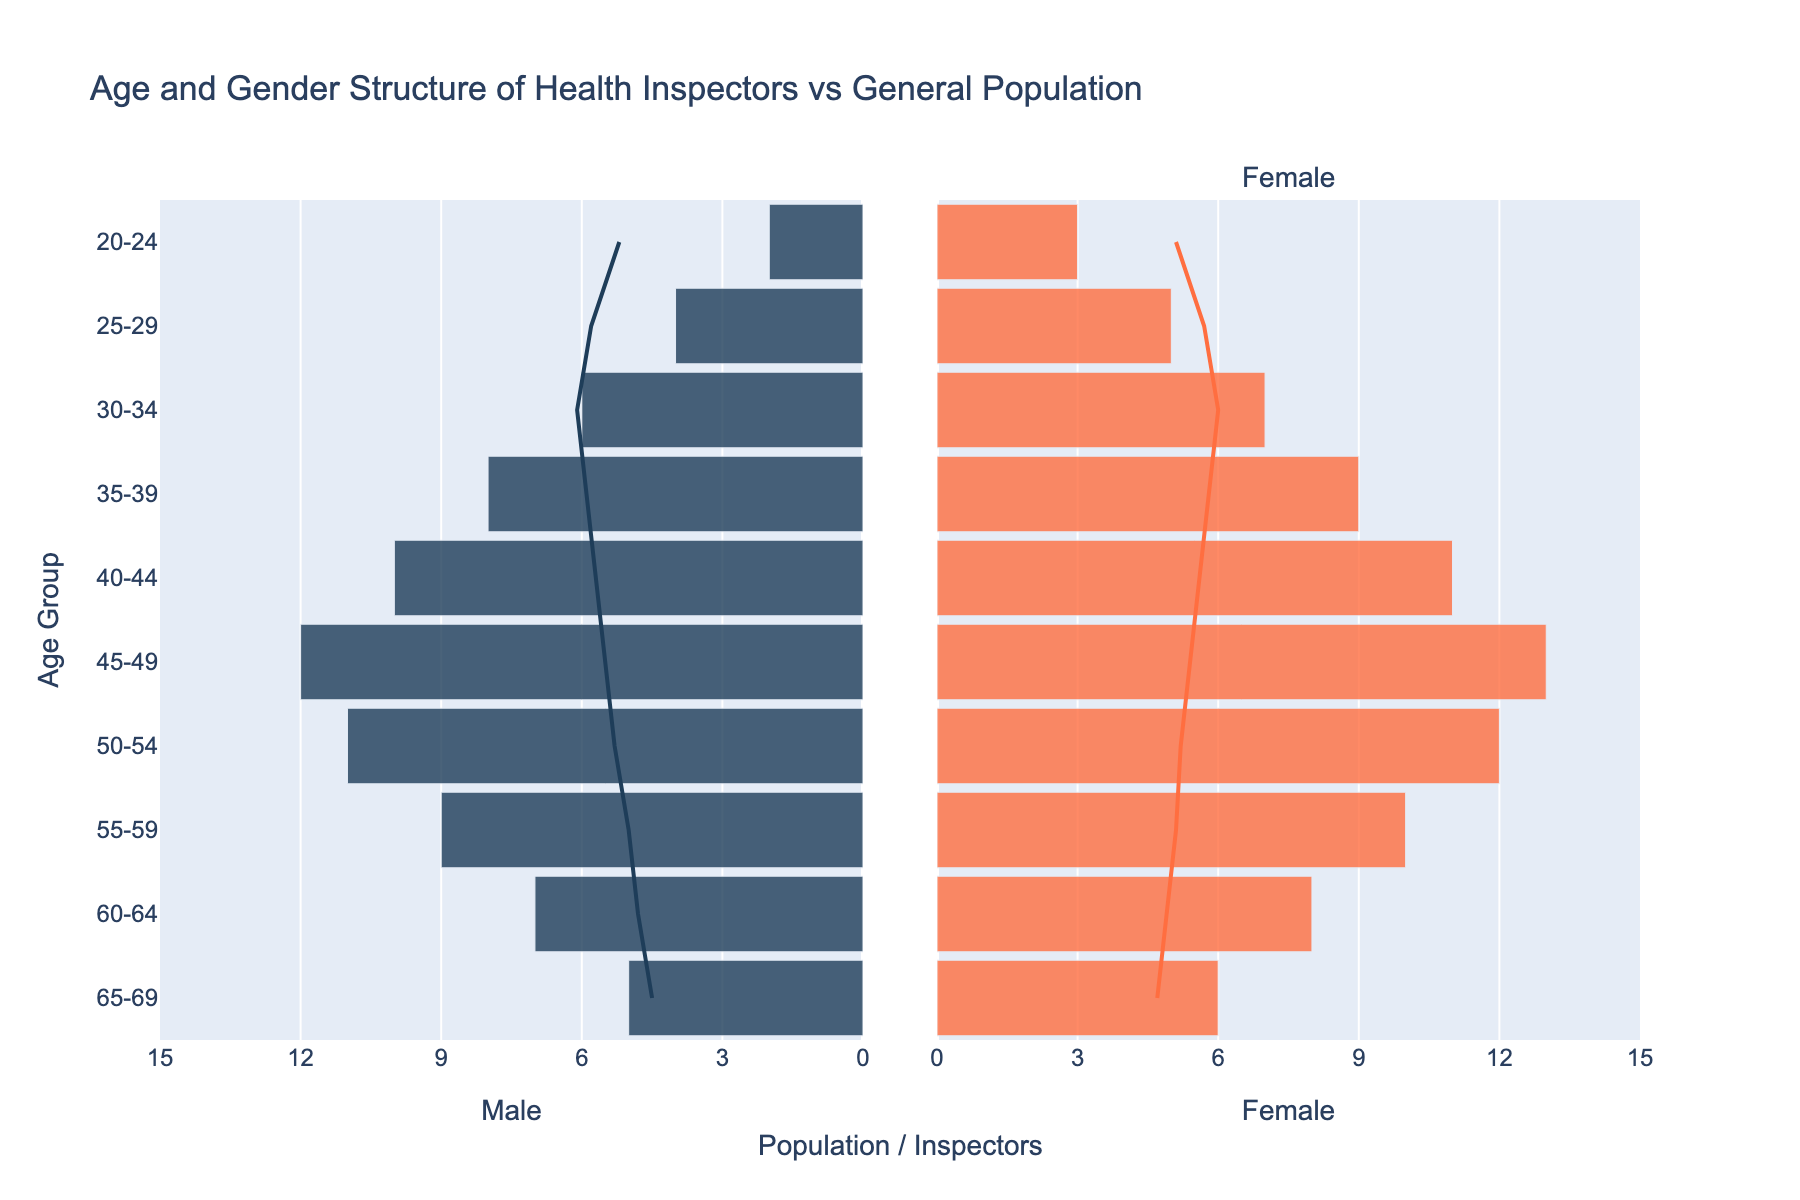What is the title of the figure? The title is usually located at the top of the figure and serves to give a brief idea about the content of the graph. In this case, it mentions the comparison of health inspectors and general population by age and gender.
Answer: Age and Gender Structure of Health Inspectors vs General Population What is the age group with the highest number of female health inspectors? By looking at the horizontal bar lengths on the right side of the population pyramid, we find the longest bar, indicating the largest number. For female health inspectors, the age group 45-49 has the longest bar.
Answer: 45-49 How do the numbers of male and female health inspectors in the 30-34 age group compare? In the 30-34 age group, the lengths of the bars on the left side (male inspectors) and right side (female inspectors) are almost even, representing 6 male inspectors and 7 female inspectors.
Answer: 6 male inspectors and 7 female inspectors Which age group shows the largest difference between male and female populations? To find this, we look at the gaps between the male and female population lines across age groups. The largest difference can be seen in the 65-69 age group where the male line falls short of the female line.
Answer: 65-69 How do the male and female populations compare across different age groups? By examining the lines representing the general population on both sides, we can see that the lines follow a similar pattern but deviate slightly in older age groups, like 65-69, where more females are present than males.
Answer: Females outnumber males, especially in older age groups In which age group are the male inspectors most overrepresented compared to the general male population? By comparing the lengths of the male inspectors' bars to the male population lines, we can identify that the age group 45-49 has a significantly larger bar for male inspectors compared to the general male population.
Answer: 45-49 Are there more female health inspectors or male health inspectors in their late 40s (45-49)? Comparing the lengths of the respective bars (12 for males and 13 for females) in the age group 45-49 shows that there is one more female health inspector than male health inspector.
Answer: Female health inspectors How does the number of inspectors change as the age group increases from 20-24 to 40-44? By observing the trend of the bars from younger to older age groups, it is apparent that the number of inspectors increases, reaching a peak in the 45-49 age group.
Answer: It increases What color represents male health inspectors in the figure? The color of the horizontal bars on the left side of the pyramid, representing male health inspectors, can be easily identified as dark blue.
Answer: Dark blue 